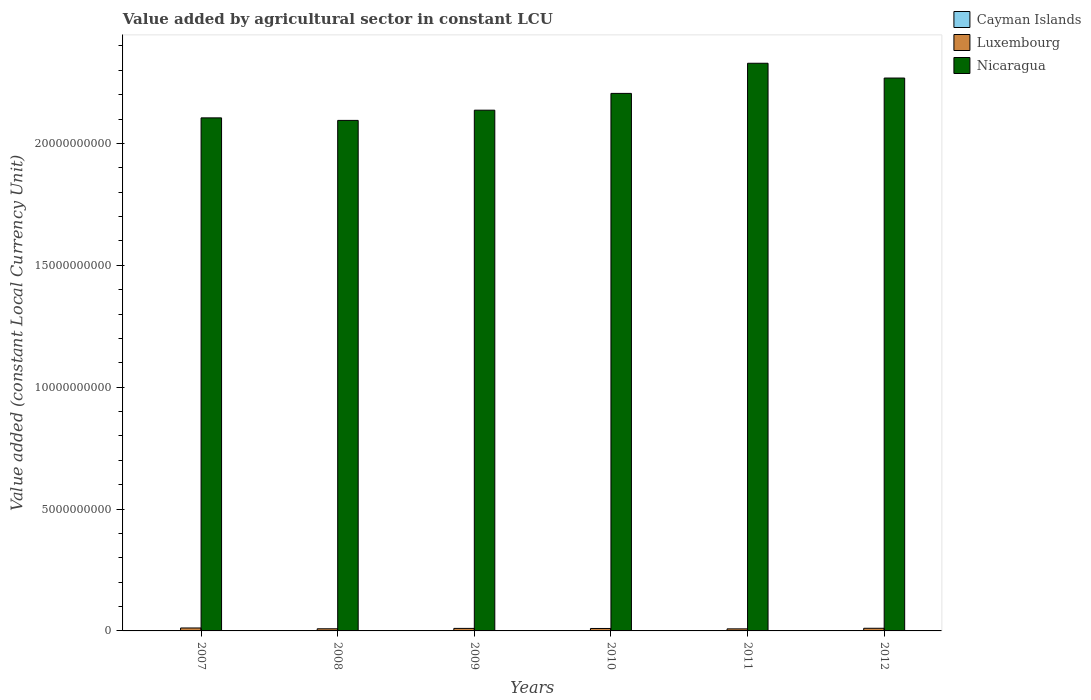How many different coloured bars are there?
Provide a short and direct response. 3. How many groups of bars are there?
Your answer should be compact. 6. Are the number of bars on each tick of the X-axis equal?
Provide a succinct answer. Yes. How many bars are there on the 5th tick from the left?
Provide a short and direct response. 3. How many bars are there on the 3rd tick from the right?
Provide a short and direct response. 3. What is the value added by agricultural sector in Luxembourg in 2008?
Give a very brief answer. 8.76e+07. Across all years, what is the maximum value added by agricultural sector in Nicaragua?
Give a very brief answer. 2.33e+1. Across all years, what is the minimum value added by agricultural sector in Cayman Islands?
Make the answer very short. 7.65e+06. In which year was the value added by agricultural sector in Nicaragua maximum?
Ensure brevity in your answer.  2011. In which year was the value added by agricultural sector in Nicaragua minimum?
Provide a succinct answer. 2008. What is the total value added by agricultural sector in Nicaragua in the graph?
Provide a succinct answer. 1.31e+11. What is the difference between the value added by agricultural sector in Luxembourg in 2008 and that in 2010?
Give a very brief answer. -1.24e+07. What is the difference between the value added by agricultural sector in Luxembourg in 2011 and the value added by agricultural sector in Cayman Islands in 2010?
Offer a very short reply. 7.54e+07. What is the average value added by agricultural sector in Luxembourg per year?
Give a very brief answer. 1.01e+08. In the year 2007, what is the difference between the value added by agricultural sector in Luxembourg and value added by agricultural sector in Nicaragua?
Provide a succinct answer. -2.09e+1. In how many years, is the value added by agricultural sector in Nicaragua greater than 12000000000 LCU?
Your answer should be very brief. 6. What is the ratio of the value added by agricultural sector in Luxembourg in 2008 to that in 2010?
Give a very brief answer. 0.88. Is the value added by agricultural sector in Nicaragua in 2011 less than that in 2012?
Your response must be concise. No. What is the difference between the highest and the second highest value added by agricultural sector in Luxembourg?
Make the answer very short. 1.19e+07. What is the difference between the highest and the lowest value added by agricultural sector in Cayman Islands?
Give a very brief answer. 1.66e+06. In how many years, is the value added by agricultural sector in Nicaragua greater than the average value added by agricultural sector in Nicaragua taken over all years?
Your answer should be very brief. 3. What does the 3rd bar from the left in 2011 represents?
Your answer should be very brief. Nicaragua. What does the 2nd bar from the right in 2007 represents?
Your response must be concise. Luxembourg. Is it the case that in every year, the sum of the value added by agricultural sector in Luxembourg and value added by agricultural sector in Nicaragua is greater than the value added by agricultural sector in Cayman Islands?
Offer a terse response. Yes. How many bars are there?
Your response must be concise. 18. How many years are there in the graph?
Make the answer very short. 6. How many legend labels are there?
Provide a succinct answer. 3. How are the legend labels stacked?
Your answer should be very brief. Vertical. What is the title of the graph?
Provide a succinct answer. Value added by agricultural sector in constant LCU. What is the label or title of the Y-axis?
Keep it short and to the point. Value added (constant Local Currency Unit). What is the Value added (constant Local Currency Unit) in Cayman Islands in 2007?
Offer a very short reply. 7.65e+06. What is the Value added (constant Local Currency Unit) in Luxembourg in 2007?
Give a very brief answer. 1.21e+08. What is the Value added (constant Local Currency Unit) in Nicaragua in 2007?
Provide a succinct answer. 2.10e+1. What is the Value added (constant Local Currency Unit) of Cayman Islands in 2008?
Offer a very short reply. 8.07e+06. What is the Value added (constant Local Currency Unit) in Luxembourg in 2008?
Your answer should be compact. 8.76e+07. What is the Value added (constant Local Currency Unit) of Nicaragua in 2008?
Make the answer very short. 2.09e+1. What is the Value added (constant Local Currency Unit) of Cayman Islands in 2009?
Make the answer very short. 8.89e+06. What is the Value added (constant Local Currency Unit) in Luxembourg in 2009?
Make the answer very short. 1.03e+08. What is the Value added (constant Local Currency Unit) of Nicaragua in 2009?
Your response must be concise. 2.14e+1. What is the Value added (constant Local Currency Unit) of Cayman Islands in 2010?
Offer a very short reply. 8.76e+06. What is the Value added (constant Local Currency Unit) in Nicaragua in 2010?
Your answer should be compact. 2.21e+1. What is the Value added (constant Local Currency Unit) in Cayman Islands in 2011?
Provide a succinct answer. 9.08e+06. What is the Value added (constant Local Currency Unit) in Luxembourg in 2011?
Your response must be concise. 8.42e+07. What is the Value added (constant Local Currency Unit) in Nicaragua in 2011?
Make the answer very short. 2.33e+1. What is the Value added (constant Local Currency Unit) in Cayman Islands in 2012?
Provide a succinct answer. 9.31e+06. What is the Value added (constant Local Currency Unit) in Luxembourg in 2012?
Give a very brief answer. 1.09e+08. What is the Value added (constant Local Currency Unit) of Nicaragua in 2012?
Keep it short and to the point. 2.27e+1. Across all years, what is the maximum Value added (constant Local Currency Unit) of Cayman Islands?
Keep it short and to the point. 9.31e+06. Across all years, what is the maximum Value added (constant Local Currency Unit) of Luxembourg?
Provide a short and direct response. 1.21e+08. Across all years, what is the maximum Value added (constant Local Currency Unit) in Nicaragua?
Ensure brevity in your answer.  2.33e+1. Across all years, what is the minimum Value added (constant Local Currency Unit) of Cayman Islands?
Provide a succinct answer. 7.65e+06. Across all years, what is the minimum Value added (constant Local Currency Unit) in Luxembourg?
Your answer should be very brief. 8.42e+07. Across all years, what is the minimum Value added (constant Local Currency Unit) of Nicaragua?
Give a very brief answer. 2.09e+1. What is the total Value added (constant Local Currency Unit) in Cayman Islands in the graph?
Your answer should be very brief. 5.18e+07. What is the total Value added (constant Local Currency Unit) in Luxembourg in the graph?
Offer a terse response. 6.05e+08. What is the total Value added (constant Local Currency Unit) of Nicaragua in the graph?
Make the answer very short. 1.31e+11. What is the difference between the Value added (constant Local Currency Unit) of Cayman Islands in 2007 and that in 2008?
Keep it short and to the point. -4.19e+05. What is the difference between the Value added (constant Local Currency Unit) in Luxembourg in 2007 and that in 2008?
Offer a terse response. 3.32e+07. What is the difference between the Value added (constant Local Currency Unit) in Nicaragua in 2007 and that in 2008?
Provide a succinct answer. 1.03e+08. What is the difference between the Value added (constant Local Currency Unit) in Cayman Islands in 2007 and that in 2009?
Provide a short and direct response. -1.24e+06. What is the difference between the Value added (constant Local Currency Unit) in Luxembourg in 2007 and that in 2009?
Your answer should be very brief. 1.75e+07. What is the difference between the Value added (constant Local Currency Unit) of Nicaragua in 2007 and that in 2009?
Your response must be concise. -3.16e+08. What is the difference between the Value added (constant Local Currency Unit) in Cayman Islands in 2007 and that in 2010?
Keep it short and to the point. -1.11e+06. What is the difference between the Value added (constant Local Currency Unit) in Luxembourg in 2007 and that in 2010?
Ensure brevity in your answer.  2.08e+07. What is the difference between the Value added (constant Local Currency Unit) of Nicaragua in 2007 and that in 2010?
Your answer should be compact. -1.00e+09. What is the difference between the Value added (constant Local Currency Unit) of Cayman Islands in 2007 and that in 2011?
Offer a very short reply. -1.43e+06. What is the difference between the Value added (constant Local Currency Unit) in Luxembourg in 2007 and that in 2011?
Your response must be concise. 3.66e+07. What is the difference between the Value added (constant Local Currency Unit) in Nicaragua in 2007 and that in 2011?
Your answer should be very brief. -2.24e+09. What is the difference between the Value added (constant Local Currency Unit) in Cayman Islands in 2007 and that in 2012?
Provide a succinct answer. -1.66e+06. What is the difference between the Value added (constant Local Currency Unit) in Luxembourg in 2007 and that in 2012?
Your answer should be compact. 1.19e+07. What is the difference between the Value added (constant Local Currency Unit) of Nicaragua in 2007 and that in 2012?
Your answer should be compact. -1.63e+09. What is the difference between the Value added (constant Local Currency Unit) of Cayman Islands in 2008 and that in 2009?
Ensure brevity in your answer.  -8.25e+05. What is the difference between the Value added (constant Local Currency Unit) in Luxembourg in 2008 and that in 2009?
Your response must be concise. -1.57e+07. What is the difference between the Value added (constant Local Currency Unit) in Nicaragua in 2008 and that in 2009?
Your response must be concise. -4.19e+08. What is the difference between the Value added (constant Local Currency Unit) in Cayman Islands in 2008 and that in 2010?
Your answer should be compact. -6.94e+05. What is the difference between the Value added (constant Local Currency Unit) in Luxembourg in 2008 and that in 2010?
Offer a very short reply. -1.24e+07. What is the difference between the Value added (constant Local Currency Unit) in Nicaragua in 2008 and that in 2010?
Provide a succinct answer. -1.11e+09. What is the difference between the Value added (constant Local Currency Unit) in Cayman Islands in 2008 and that in 2011?
Keep it short and to the point. -1.01e+06. What is the difference between the Value added (constant Local Currency Unit) of Luxembourg in 2008 and that in 2011?
Ensure brevity in your answer.  3.40e+06. What is the difference between the Value added (constant Local Currency Unit) in Nicaragua in 2008 and that in 2011?
Your answer should be very brief. -2.34e+09. What is the difference between the Value added (constant Local Currency Unit) in Cayman Islands in 2008 and that in 2012?
Offer a very short reply. -1.24e+06. What is the difference between the Value added (constant Local Currency Unit) in Luxembourg in 2008 and that in 2012?
Give a very brief answer. -2.13e+07. What is the difference between the Value added (constant Local Currency Unit) in Nicaragua in 2008 and that in 2012?
Provide a short and direct response. -1.74e+09. What is the difference between the Value added (constant Local Currency Unit) in Cayman Islands in 2009 and that in 2010?
Offer a very short reply. 1.30e+05. What is the difference between the Value added (constant Local Currency Unit) in Luxembourg in 2009 and that in 2010?
Ensure brevity in your answer.  3.30e+06. What is the difference between the Value added (constant Local Currency Unit) in Nicaragua in 2009 and that in 2010?
Your answer should be very brief. -6.89e+08. What is the difference between the Value added (constant Local Currency Unit) in Cayman Islands in 2009 and that in 2011?
Provide a short and direct response. -1.88e+05. What is the difference between the Value added (constant Local Currency Unit) of Luxembourg in 2009 and that in 2011?
Your response must be concise. 1.91e+07. What is the difference between the Value added (constant Local Currency Unit) in Nicaragua in 2009 and that in 2011?
Your answer should be very brief. -1.92e+09. What is the difference between the Value added (constant Local Currency Unit) in Cayman Islands in 2009 and that in 2012?
Keep it short and to the point. -4.13e+05. What is the difference between the Value added (constant Local Currency Unit) of Luxembourg in 2009 and that in 2012?
Ensure brevity in your answer.  -5.60e+06. What is the difference between the Value added (constant Local Currency Unit) of Nicaragua in 2009 and that in 2012?
Keep it short and to the point. -1.32e+09. What is the difference between the Value added (constant Local Currency Unit) of Cayman Islands in 2010 and that in 2011?
Offer a very short reply. -3.18e+05. What is the difference between the Value added (constant Local Currency Unit) of Luxembourg in 2010 and that in 2011?
Your answer should be compact. 1.58e+07. What is the difference between the Value added (constant Local Currency Unit) of Nicaragua in 2010 and that in 2011?
Offer a very short reply. -1.24e+09. What is the difference between the Value added (constant Local Currency Unit) of Cayman Islands in 2010 and that in 2012?
Provide a succinct answer. -5.44e+05. What is the difference between the Value added (constant Local Currency Unit) in Luxembourg in 2010 and that in 2012?
Offer a terse response. -8.90e+06. What is the difference between the Value added (constant Local Currency Unit) in Nicaragua in 2010 and that in 2012?
Provide a short and direct response. -6.30e+08. What is the difference between the Value added (constant Local Currency Unit) of Cayman Islands in 2011 and that in 2012?
Make the answer very short. -2.25e+05. What is the difference between the Value added (constant Local Currency Unit) of Luxembourg in 2011 and that in 2012?
Your answer should be compact. -2.47e+07. What is the difference between the Value added (constant Local Currency Unit) of Nicaragua in 2011 and that in 2012?
Give a very brief answer. 6.07e+08. What is the difference between the Value added (constant Local Currency Unit) of Cayman Islands in 2007 and the Value added (constant Local Currency Unit) of Luxembourg in 2008?
Keep it short and to the point. -8.00e+07. What is the difference between the Value added (constant Local Currency Unit) of Cayman Islands in 2007 and the Value added (constant Local Currency Unit) of Nicaragua in 2008?
Keep it short and to the point. -2.09e+1. What is the difference between the Value added (constant Local Currency Unit) in Luxembourg in 2007 and the Value added (constant Local Currency Unit) in Nicaragua in 2008?
Keep it short and to the point. -2.08e+1. What is the difference between the Value added (constant Local Currency Unit) of Cayman Islands in 2007 and the Value added (constant Local Currency Unit) of Luxembourg in 2009?
Your answer should be compact. -9.57e+07. What is the difference between the Value added (constant Local Currency Unit) in Cayman Islands in 2007 and the Value added (constant Local Currency Unit) in Nicaragua in 2009?
Offer a terse response. -2.14e+1. What is the difference between the Value added (constant Local Currency Unit) of Luxembourg in 2007 and the Value added (constant Local Currency Unit) of Nicaragua in 2009?
Keep it short and to the point. -2.12e+1. What is the difference between the Value added (constant Local Currency Unit) of Cayman Islands in 2007 and the Value added (constant Local Currency Unit) of Luxembourg in 2010?
Make the answer very short. -9.24e+07. What is the difference between the Value added (constant Local Currency Unit) in Cayman Islands in 2007 and the Value added (constant Local Currency Unit) in Nicaragua in 2010?
Ensure brevity in your answer.  -2.20e+1. What is the difference between the Value added (constant Local Currency Unit) of Luxembourg in 2007 and the Value added (constant Local Currency Unit) of Nicaragua in 2010?
Keep it short and to the point. -2.19e+1. What is the difference between the Value added (constant Local Currency Unit) in Cayman Islands in 2007 and the Value added (constant Local Currency Unit) in Luxembourg in 2011?
Provide a short and direct response. -7.66e+07. What is the difference between the Value added (constant Local Currency Unit) in Cayman Islands in 2007 and the Value added (constant Local Currency Unit) in Nicaragua in 2011?
Your answer should be compact. -2.33e+1. What is the difference between the Value added (constant Local Currency Unit) of Luxembourg in 2007 and the Value added (constant Local Currency Unit) of Nicaragua in 2011?
Make the answer very short. -2.32e+1. What is the difference between the Value added (constant Local Currency Unit) in Cayman Islands in 2007 and the Value added (constant Local Currency Unit) in Luxembourg in 2012?
Ensure brevity in your answer.  -1.01e+08. What is the difference between the Value added (constant Local Currency Unit) of Cayman Islands in 2007 and the Value added (constant Local Currency Unit) of Nicaragua in 2012?
Your answer should be very brief. -2.27e+1. What is the difference between the Value added (constant Local Currency Unit) of Luxembourg in 2007 and the Value added (constant Local Currency Unit) of Nicaragua in 2012?
Make the answer very short. -2.26e+1. What is the difference between the Value added (constant Local Currency Unit) in Cayman Islands in 2008 and the Value added (constant Local Currency Unit) in Luxembourg in 2009?
Keep it short and to the point. -9.52e+07. What is the difference between the Value added (constant Local Currency Unit) in Cayman Islands in 2008 and the Value added (constant Local Currency Unit) in Nicaragua in 2009?
Your answer should be very brief. -2.14e+1. What is the difference between the Value added (constant Local Currency Unit) in Luxembourg in 2008 and the Value added (constant Local Currency Unit) in Nicaragua in 2009?
Offer a very short reply. -2.13e+1. What is the difference between the Value added (constant Local Currency Unit) of Cayman Islands in 2008 and the Value added (constant Local Currency Unit) of Luxembourg in 2010?
Keep it short and to the point. -9.19e+07. What is the difference between the Value added (constant Local Currency Unit) in Cayman Islands in 2008 and the Value added (constant Local Currency Unit) in Nicaragua in 2010?
Offer a very short reply. -2.20e+1. What is the difference between the Value added (constant Local Currency Unit) in Luxembourg in 2008 and the Value added (constant Local Currency Unit) in Nicaragua in 2010?
Ensure brevity in your answer.  -2.20e+1. What is the difference between the Value added (constant Local Currency Unit) in Cayman Islands in 2008 and the Value added (constant Local Currency Unit) in Luxembourg in 2011?
Your answer should be very brief. -7.61e+07. What is the difference between the Value added (constant Local Currency Unit) in Cayman Islands in 2008 and the Value added (constant Local Currency Unit) in Nicaragua in 2011?
Provide a succinct answer. -2.33e+1. What is the difference between the Value added (constant Local Currency Unit) in Luxembourg in 2008 and the Value added (constant Local Currency Unit) in Nicaragua in 2011?
Ensure brevity in your answer.  -2.32e+1. What is the difference between the Value added (constant Local Currency Unit) in Cayman Islands in 2008 and the Value added (constant Local Currency Unit) in Luxembourg in 2012?
Make the answer very short. -1.01e+08. What is the difference between the Value added (constant Local Currency Unit) of Cayman Islands in 2008 and the Value added (constant Local Currency Unit) of Nicaragua in 2012?
Your answer should be compact. -2.27e+1. What is the difference between the Value added (constant Local Currency Unit) of Luxembourg in 2008 and the Value added (constant Local Currency Unit) of Nicaragua in 2012?
Your answer should be very brief. -2.26e+1. What is the difference between the Value added (constant Local Currency Unit) of Cayman Islands in 2009 and the Value added (constant Local Currency Unit) of Luxembourg in 2010?
Offer a very short reply. -9.11e+07. What is the difference between the Value added (constant Local Currency Unit) in Cayman Islands in 2009 and the Value added (constant Local Currency Unit) in Nicaragua in 2010?
Ensure brevity in your answer.  -2.20e+1. What is the difference between the Value added (constant Local Currency Unit) in Luxembourg in 2009 and the Value added (constant Local Currency Unit) in Nicaragua in 2010?
Make the answer very short. -2.19e+1. What is the difference between the Value added (constant Local Currency Unit) in Cayman Islands in 2009 and the Value added (constant Local Currency Unit) in Luxembourg in 2011?
Offer a very short reply. -7.53e+07. What is the difference between the Value added (constant Local Currency Unit) of Cayman Islands in 2009 and the Value added (constant Local Currency Unit) of Nicaragua in 2011?
Ensure brevity in your answer.  -2.33e+1. What is the difference between the Value added (constant Local Currency Unit) of Luxembourg in 2009 and the Value added (constant Local Currency Unit) of Nicaragua in 2011?
Offer a very short reply. -2.32e+1. What is the difference between the Value added (constant Local Currency Unit) in Cayman Islands in 2009 and the Value added (constant Local Currency Unit) in Luxembourg in 2012?
Make the answer very short. -1.00e+08. What is the difference between the Value added (constant Local Currency Unit) in Cayman Islands in 2009 and the Value added (constant Local Currency Unit) in Nicaragua in 2012?
Ensure brevity in your answer.  -2.27e+1. What is the difference between the Value added (constant Local Currency Unit) of Luxembourg in 2009 and the Value added (constant Local Currency Unit) of Nicaragua in 2012?
Keep it short and to the point. -2.26e+1. What is the difference between the Value added (constant Local Currency Unit) in Cayman Islands in 2010 and the Value added (constant Local Currency Unit) in Luxembourg in 2011?
Ensure brevity in your answer.  -7.54e+07. What is the difference between the Value added (constant Local Currency Unit) of Cayman Islands in 2010 and the Value added (constant Local Currency Unit) of Nicaragua in 2011?
Ensure brevity in your answer.  -2.33e+1. What is the difference between the Value added (constant Local Currency Unit) in Luxembourg in 2010 and the Value added (constant Local Currency Unit) in Nicaragua in 2011?
Ensure brevity in your answer.  -2.32e+1. What is the difference between the Value added (constant Local Currency Unit) of Cayman Islands in 2010 and the Value added (constant Local Currency Unit) of Luxembourg in 2012?
Provide a short and direct response. -1.00e+08. What is the difference between the Value added (constant Local Currency Unit) of Cayman Islands in 2010 and the Value added (constant Local Currency Unit) of Nicaragua in 2012?
Make the answer very short. -2.27e+1. What is the difference between the Value added (constant Local Currency Unit) in Luxembourg in 2010 and the Value added (constant Local Currency Unit) in Nicaragua in 2012?
Your answer should be compact. -2.26e+1. What is the difference between the Value added (constant Local Currency Unit) of Cayman Islands in 2011 and the Value added (constant Local Currency Unit) of Luxembourg in 2012?
Provide a short and direct response. -9.98e+07. What is the difference between the Value added (constant Local Currency Unit) of Cayman Islands in 2011 and the Value added (constant Local Currency Unit) of Nicaragua in 2012?
Ensure brevity in your answer.  -2.27e+1. What is the difference between the Value added (constant Local Currency Unit) in Luxembourg in 2011 and the Value added (constant Local Currency Unit) in Nicaragua in 2012?
Keep it short and to the point. -2.26e+1. What is the average Value added (constant Local Currency Unit) of Cayman Islands per year?
Offer a very short reply. 8.63e+06. What is the average Value added (constant Local Currency Unit) in Luxembourg per year?
Make the answer very short. 1.01e+08. What is the average Value added (constant Local Currency Unit) of Nicaragua per year?
Your answer should be compact. 2.19e+1. In the year 2007, what is the difference between the Value added (constant Local Currency Unit) of Cayman Islands and Value added (constant Local Currency Unit) of Luxembourg?
Offer a terse response. -1.13e+08. In the year 2007, what is the difference between the Value added (constant Local Currency Unit) of Cayman Islands and Value added (constant Local Currency Unit) of Nicaragua?
Make the answer very short. -2.10e+1. In the year 2007, what is the difference between the Value added (constant Local Currency Unit) of Luxembourg and Value added (constant Local Currency Unit) of Nicaragua?
Your answer should be very brief. -2.09e+1. In the year 2008, what is the difference between the Value added (constant Local Currency Unit) of Cayman Islands and Value added (constant Local Currency Unit) of Luxembourg?
Your answer should be compact. -7.95e+07. In the year 2008, what is the difference between the Value added (constant Local Currency Unit) of Cayman Islands and Value added (constant Local Currency Unit) of Nicaragua?
Ensure brevity in your answer.  -2.09e+1. In the year 2008, what is the difference between the Value added (constant Local Currency Unit) of Luxembourg and Value added (constant Local Currency Unit) of Nicaragua?
Make the answer very short. -2.09e+1. In the year 2009, what is the difference between the Value added (constant Local Currency Unit) in Cayman Islands and Value added (constant Local Currency Unit) in Luxembourg?
Ensure brevity in your answer.  -9.44e+07. In the year 2009, what is the difference between the Value added (constant Local Currency Unit) in Cayman Islands and Value added (constant Local Currency Unit) in Nicaragua?
Ensure brevity in your answer.  -2.14e+1. In the year 2009, what is the difference between the Value added (constant Local Currency Unit) in Luxembourg and Value added (constant Local Currency Unit) in Nicaragua?
Provide a short and direct response. -2.13e+1. In the year 2010, what is the difference between the Value added (constant Local Currency Unit) of Cayman Islands and Value added (constant Local Currency Unit) of Luxembourg?
Make the answer very short. -9.12e+07. In the year 2010, what is the difference between the Value added (constant Local Currency Unit) of Cayman Islands and Value added (constant Local Currency Unit) of Nicaragua?
Offer a terse response. -2.20e+1. In the year 2010, what is the difference between the Value added (constant Local Currency Unit) in Luxembourg and Value added (constant Local Currency Unit) in Nicaragua?
Your answer should be very brief. -2.20e+1. In the year 2011, what is the difference between the Value added (constant Local Currency Unit) in Cayman Islands and Value added (constant Local Currency Unit) in Luxembourg?
Your answer should be compact. -7.51e+07. In the year 2011, what is the difference between the Value added (constant Local Currency Unit) of Cayman Islands and Value added (constant Local Currency Unit) of Nicaragua?
Give a very brief answer. -2.33e+1. In the year 2011, what is the difference between the Value added (constant Local Currency Unit) in Luxembourg and Value added (constant Local Currency Unit) in Nicaragua?
Your answer should be compact. -2.32e+1. In the year 2012, what is the difference between the Value added (constant Local Currency Unit) in Cayman Islands and Value added (constant Local Currency Unit) in Luxembourg?
Your answer should be compact. -9.96e+07. In the year 2012, what is the difference between the Value added (constant Local Currency Unit) of Cayman Islands and Value added (constant Local Currency Unit) of Nicaragua?
Offer a terse response. -2.27e+1. In the year 2012, what is the difference between the Value added (constant Local Currency Unit) in Luxembourg and Value added (constant Local Currency Unit) in Nicaragua?
Make the answer very short. -2.26e+1. What is the ratio of the Value added (constant Local Currency Unit) in Cayman Islands in 2007 to that in 2008?
Provide a short and direct response. 0.95. What is the ratio of the Value added (constant Local Currency Unit) of Luxembourg in 2007 to that in 2008?
Offer a terse response. 1.38. What is the ratio of the Value added (constant Local Currency Unit) of Nicaragua in 2007 to that in 2008?
Your answer should be compact. 1. What is the ratio of the Value added (constant Local Currency Unit) in Cayman Islands in 2007 to that in 2009?
Your answer should be compact. 0.86. What is the ratio of the Value added (constant Local Currency Unit) in Luxembourg in 2007 to that in 2009?
Keep it short and to the point. 1.17. What is the ratio of the Value added (constant Local Currency Unit) of Nicaragua in 2007 to that in 2009?
Your response must be concise. 0.99. What is the ratio of the Value added (constant Local Currency Unit) in Cayman Islands in 2007 to that in 2010?
Your response must be concise. 0.87. What is the ratio of the Value added (constant Local Currency Unit) in Luxembourg in 2007 to that in 2010?
Offer a terse response. 1.21. What is the ratio of the Value added (constant Local Currency Unit) in Nicaragua in 2007 to that in 2010?
Keep it short and to the point. 0.95. What is the ratio of the Value added (constant Local Currency Unit) of Cayman Islands in 2007 to that in 2011?
Your answer should be very brief. 0.84. What is the ratio of the Value added (constant Local Currency Unit) in Luxembourg in 2007 to that in 2011?
Provide a succinct answer. 1.43. What is the ratio of the Value added (constant Local Currency Unit) in Nicaragua in 2007 to that in 2011?
Keep it short and to the point. 0.9. What is the ratio of the Value added (constant Local Currency Unit) of Cayman Islands in 2007 to that in 2012?
Ensure brevity in your answer.  0.82. What is the ratio of the Value added (constant Local Currency Unit) in Luxembourg in 2007 to that in 2012?
Your answer should be compact. 1.11. What is the ratio of the Value added (constant Local Currency Unit) of Nicaragua in 2007 to that in 2012?
Offer a terse response. 0.93. What is the ratio of the Value added (constant Local Currency Unit) of Cayman Islands in 2008 to that in 2009?
Provide a succinct answer. 0.91. What is the ratio of the Value added (constant Local Currency Unit) in Luxembourg in 2008 to that in 2009?
Your answer should be compact. 0.85. What is the ratio of the Value added (constant Local Currency Unit) in Nicaragua in 2008 to that in 2009?
Provide a succinct answer. 0.98. What is the ratio of the Value added (constant Local Currency Unit) of Cayman Islands in 2008 to that in 2010?
Offer a very short reply. 0.92. What is the ratio of the Value added (constant Local Currency Unit) of Luxembourg in 2008 to that in 2010?
Your answer should be very brief. 0.88. What is the ratio of the Value added (constant Local Currency Unit) of Nicaragua in 2008 to that in 2010?
Offer a terse response. 0.95. What is the ratio of the Value added (constant Local Currency Unit) in Cayman Islands in 2008 to that in 2011?
Your answer should be very brief. 0.89. What is the ratio of the Value added (constant Local Currency Unit) of Luxembourg in 2008 to that in 2011?
Your answer should be very brief. 1.04. What is the ratio of the Value added (constant Local Currency Unit) in Nicaragua in 2008 to that in 2011?
Provide a short and direct response. 0.9. What is the ratio of the Value added (constant Local Currency Unit) in Cayman Islands in 2008 to that in 2012?
Your answer should be very brief. 0.87. What is the ratio of the Value added (constant Local Currency Unit) of Luxembourg in 2008 to that in 2012?
Make the answer very short. 0.8. What is the ratio of the Value added (constant Local Currency Unit) in Nicaragua in 2008 to that in 2012?
Your response must be concise. 0.92. What is the ratio of the Value added (constant Local Currency Unit) in Cayman Islands in 2009 to that in 2010?
Offer a terse response. 1.01. What is the ratio of the Value added (constant Local Currency Unit) in Luxembourg in 2009 to that in 2010?
Offer a terse response. 1.03. What is the ratio of the Value added (constant Local Currency Unit) of Nicaragua in 2009 to that in 2010?
Provide a short and direct response. 0.97. What is the ratio of the Value added (constant Local Currency Unit) of Cayman Islands in 2009 to that in 2011?
Ensure brevity in your answer.  0.98. What is the ratio of the Value added (constant Local Currency Unit) of Luxembourg in 2009 to that in 2011?
Provide a short and direct response. 1.23. What is the ratio of the Value added (constant Local Currency Unit) of Nicaragua in 2009 to that in 2011?
Provide a short and direct response. 0.92. What is the ratio of the Value added (constant Local Currency Unit) of Cayman Islands in 2009 to that in 2012?
Your answer should be very brief. 0.96. What is the ratio of the Value added (constant Local Currency Unit) of Luxembourg in 2009 to that in 2012?
Keep it short and to the point. 0.95. What is the ratio of the Value added (constant Local Currency Unit) in Nicaragua in 2009 to that in 2012?
Ensure brevity in your answer.  0.94. What is the ratio of the Value added (constant Local Currency Unit) in Cayman Islands in 2010 to that in 2011?
Make the answer very short. 0.96. What is the ratio of the Value added (constant Local Currency Unit) of Luxembourg in 2010 to that in 2011?
Provide a short and direct response. 1.19. What is the ratio of the Value added (constant Local Currency Unit) of Nicaragua in 2010 to that in 2011?
Keep it short and to the point. 0.95. What is the ratio of the Value added (constant Local Currency Unit) of Cayman Islands in 2010 to that in 2012?
Offer a very short reply. 0.94. What is the ratio of the Value added (constant Local Currency Unit) in Luxembourg in 2010 to that in 2012?
Your answer should be compact. 0.92. What is the ratio of the Value added (constant Local Currency Unit) in Nicaragua in 2010 to that in 2012?
Give a very brief answer. 0.97. What is the ratio of the Value added (constant Local Currency Unit) of Cayman Islands in 2011 to that in 2012?
Give a very brief answer. 0.98. What is the ratio of the Value added (constant Local Currency Unit) in Luxembourg in 2011 to that in 2012?
Your answer should be very brief. 0.77. What is the ratio of the Value added (constant Local Currency Unit) in Nicaragua in 2011 to that in 2012?
Offer a very short reply. 1.03. What is the difference between the highest and the second highest Value added (constant Local Currency Unit) in Cayman Islands?
Your answer should be very brief. 2.25e+05. What is the difference between the highest and the second highest Value added (constant Local Currency Unit) in Luxembourg?
Keep it short and to the point. 1.19e+07. What is the difference between the highest and the second highest Value added (constant Local Currency Unit) of Nicaragua?
Provide a short and direct response. 6.07e+08. What is the difference between the highest and the lowest Value added (constant Local Currency Unit) of Cayman Islands?
Your answer should be very brief. 1.66e+06. What is the difference between the highest and the lowest Value added (constant Local Currency Unit) in Luxembourg?
Offer a terse response. 3.66e+07. What is the difference between the highest and the lowest Value added (constant Local Currency Unit) in Nicaragua?
Provide a short and direct response. 2.34e+09. 